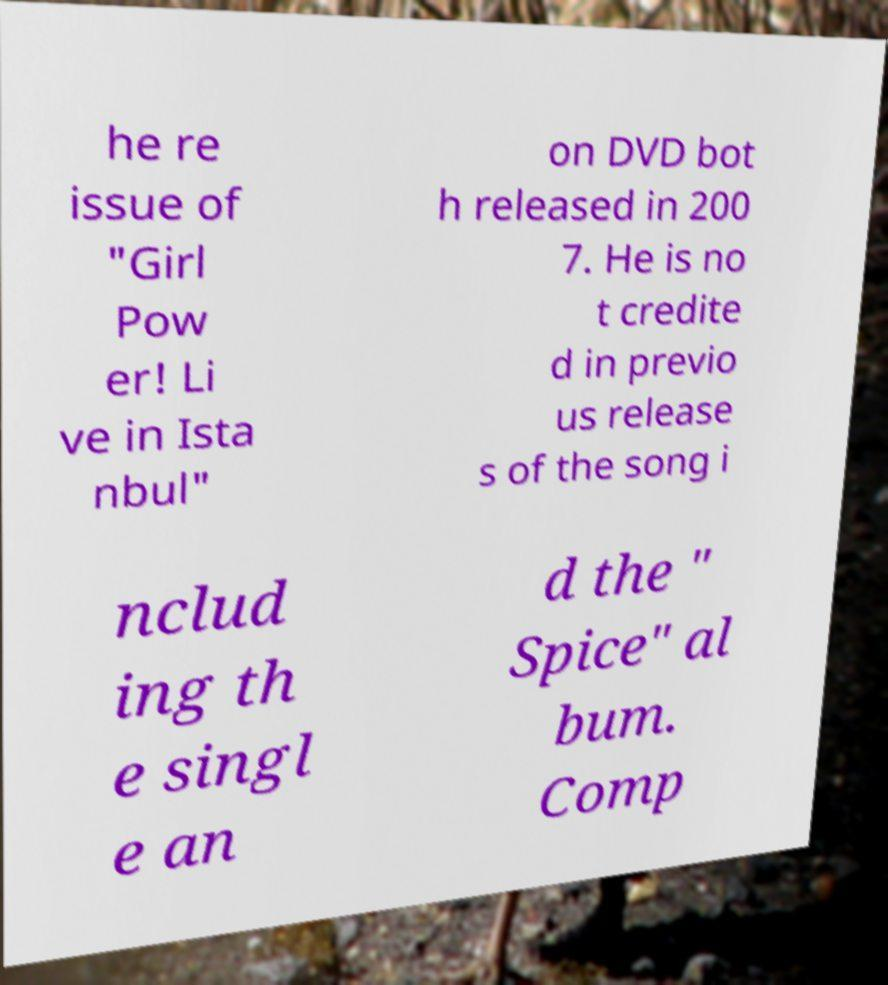There's text embedded in this image that I need extracted. Can you transcribe it verbatim? he re issue of "Girl Pow er! Li ve in Ista nbul" on DVD bot h released in 200 7. He is no t credite d in previo us release s of the song i nclud ing th e singl e an d the " Spice" al bum. Comp 